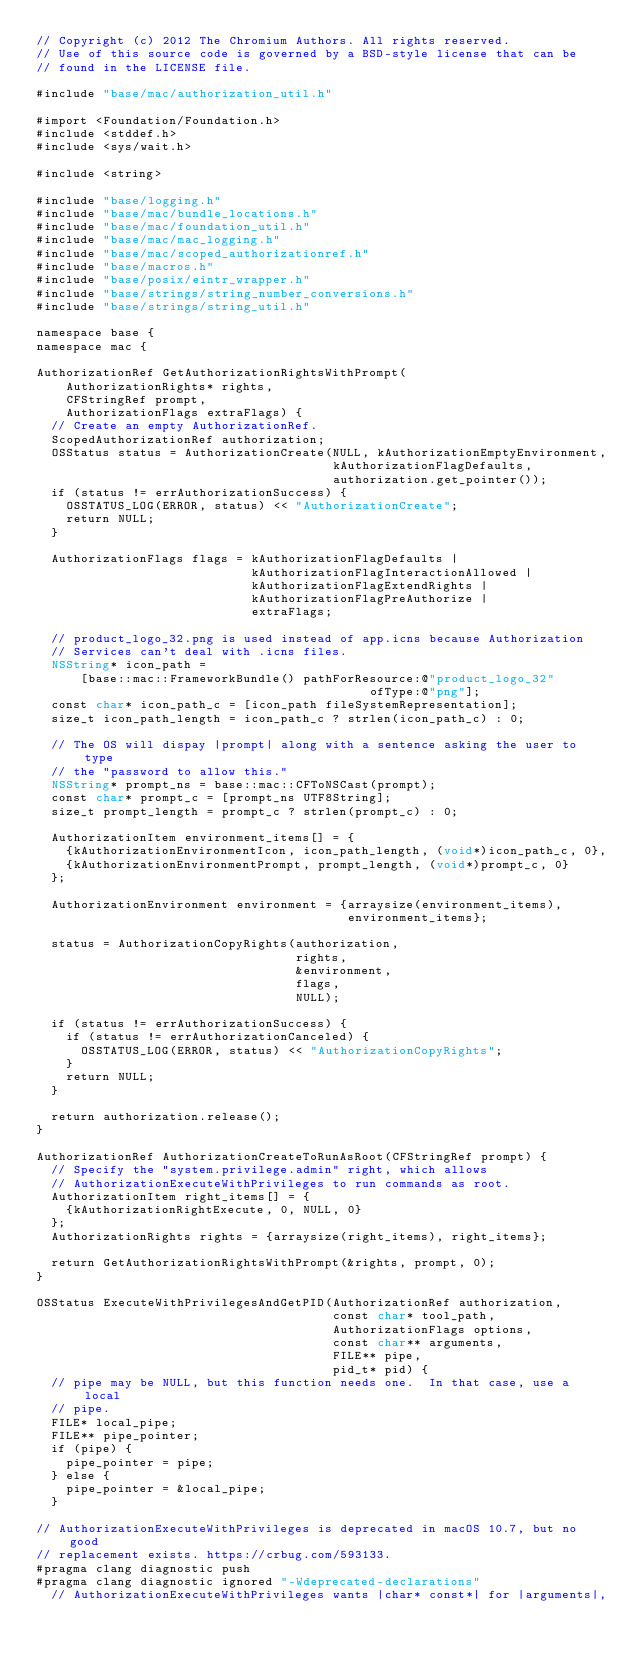Convert code to text. <code><loc_0><loc_0><loc_500><loc_500><_ObjectiveC_>// Copyright (c) 2012 The Chromium Authors. All rights reserved.
// Use of this source code is governed by a BSD-style license that can be
// found in the LICENSE file.

#include "base/mac/authorization_util.h"

#import <Foundation/Foundation.h>
#include <stddef.h>
#include <sys/wait.h>

#include <string>

#include "base/logging.h"
#include "base/mac/bundle_locations.h"
#include "base/mac/foundation_util.h"
#include "base/mac/mac_logging.h"
#include "base/mac/scoped_authorizationref.h"
#include "base/macros.h"
#include "base/posix/eintr_wrapper.h"
#include "base/strings/string_number_conversions.h"
#include "base/strings/string_util.h"

namespace base {
namespace mac {

AuthorizationRef GetAuthorizationRightsWithPrompt(
    AuthorizationRights* rights,
    CFStringRef prompt,
    AuthorizationFlags extraFlags) {
  // Create an empty AuthorizationRef.
  ScopedAuthorizationRef authorization;
  OSStatus status = AuthorizationCreate(NULL, kAuthorizationEmptyEnvironment,
                                        kAuthorizationFlagDefaults,
                                        authorization.get_pointer());
  if (status != errAuthorizationSuccess) {
    OSSTATUS_LOG(ERROR, status) << "AuthorizationCreate";
    return NULL;
  }

  AuthorizationFlags flags = kAuthorizationFlagDefaults |
                             kAuthorizationFlagInteractionAllowed |
                             kAuthorizationFlagExtendRights |
                             kAuthorizationFlagPreAuthorize |
                             extraFlags;

  // product_logo_32.png is used instead of app.icns because Authorization
  // Services can't deal with .icns files.
  NSString* icon_path =
      [base::mac::FrameworkBundle() pathForResource:@"product_logo_32"
                                             ofType:@"png"];
  const char* icon_path_c = [icon_path fileSystemRepresentation];
  size_t icon_path_length = icon_path_c ? strlen(icon_path_c) : 0;

  // The OS will dispay |prompt| along with a sentence asking the user to type
  // the "password to allow this."
  NSString* prompt_ns = base::mac::CFToNSCast(prompt);
  const char* prompt_c = [prompt_ns UTF8String];
  size_t prompt_length = prompt_c ? strlen(prompt_c) : 0;

  AuthorizationItem environment_items[] = {
    {kAuthorizationEnvironmentIcon, icon_path_length, (void*)icon_path_c, 0},
    {kAuthorizationEnvironmentPrompt, prompt_length, (void*)prompt_c, 0}
  };

  AuthorizationEnvironment environment = {arraysize(environment_items),
                                          environment_items};

  status = AuthorizationCopyRights(authorization,
                                   rights,
                                   &environment,
                                   flags,
                                   NULL);

  if (status != errAuthorizationSuccess) {
    if (status != errAuthorizationCanceled) {
      OSSTATUS_LOG(ERROR, status) << "AuthorizationCopyRights";
    }
    return NULL;
  }

  return authorization.release();
}

AuthorizationRef AuthorizationCreateToRunAsRoot(CFStringRef prompt) {
  // Specify the "system.privilege.admin" right, which allows
  // AuthorizationExecuteWithPrivileges to run commands as root.
  AuthorizationItem right_items[] = {
    {kAuthorizationRightExecute, 0, NULL, 0}
  };
  AuthorizationRights rights = {arraysize(right_items), right_items};

  return GetAuthorizationRightsWithPrompt(&rights, prompt, 0);
}

OSStatus ExecuteWithPrivilegesAndGetPID(AuthorizationRef authorization,
                                        const char* tool_path,
                                        AuthorizationFlags options,
                                        const char** arguments,
                                        FILE** pipe,
                                        pid_t* pid) {
  // pipe may be NULL, but this function needs one.  In that case, use a local
  // pipe.
  FILE* local_pipe;
  FILE** pipe_pointer;
  if (pipe) {
    pipe_pointer = pipe;
  } else {
    pipe_pointer = &local_pipe;
  }

// AuthorizationExecuteWithPrivileges is deprecated in macOS 10.7, but no good
// replacement exists. https://crbug.com/593133.
#pragma clang diagnostic push
#pragma clang diagnostic ignored "-Wdeprecated-declarations"
  // AuthorizationExecuteWithPrivileges wants |char* const*| for |arguments|,</code> 